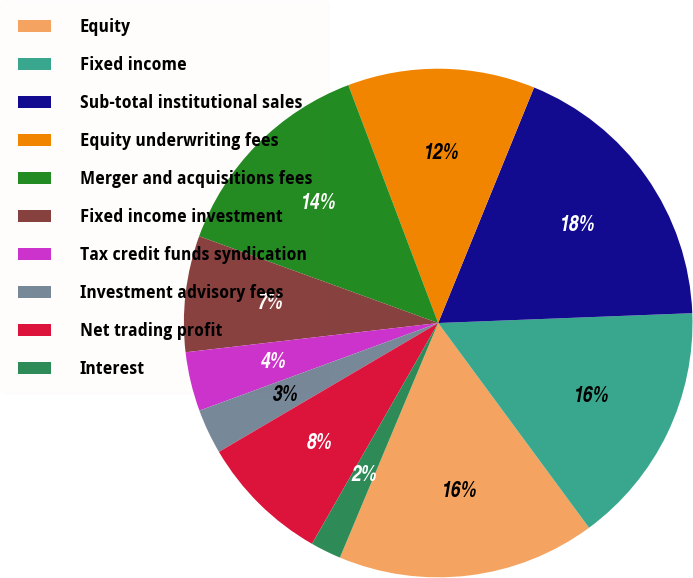<chart> <loc_0><loc_0><loc_500><loc_500><pie_chart><fcel>Equity<fcel>Fixed income<fcel>Sub-total institutional sales<fcel>Equity underwriting fees<fcel>Merger and acquisitions fees<fcel>Fixed income investment<fcel>Tax credit funds syndication<fcel>Investment advisory fees<fcel>Net trading profit<fcel>Interest<nl><fcel>16.42%<fcel>15.51%<fcel>18.23%<fcel>11.9%<fcel>13.71%<fcel>7.38%<fcel>3.76%<fcel>2.86%<fcel>8.28%<fcel>1.95%<nl></chart> 